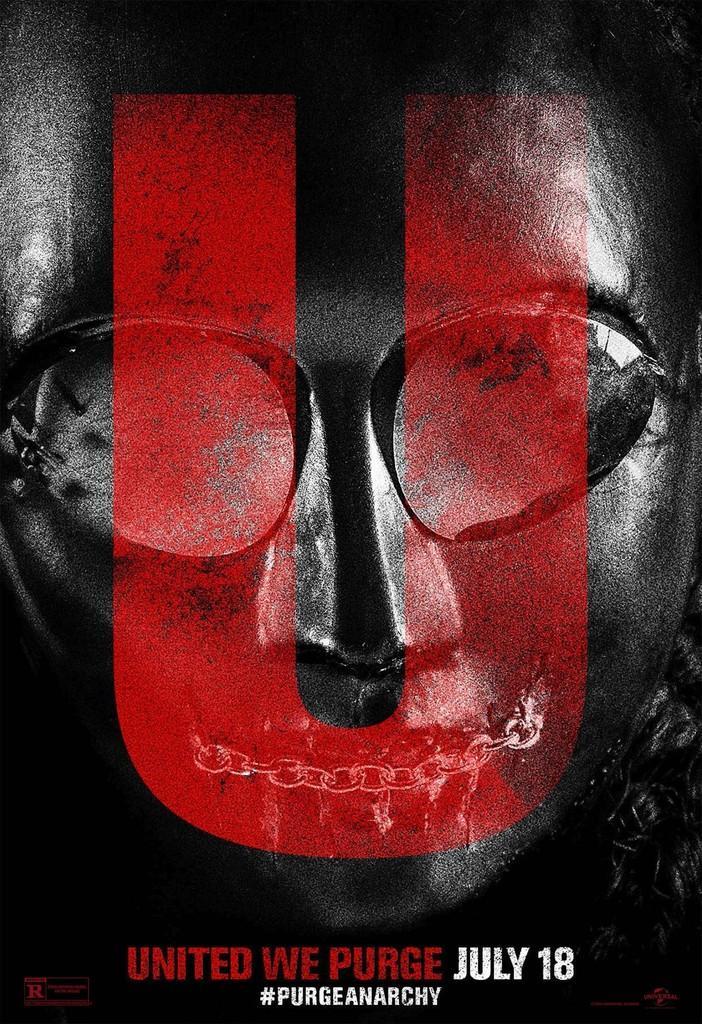How would you summarize this image in a sentence or two? In this image, there is a picture on that picture at the bottom there is UNITED WE PURGE JULY 18 written. 